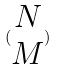Convert formula to latex. <formula><loc_0><loc_0><loc_500><loc_500>( \begin{matrix} N \\ M \end{matrix} )</formula> 